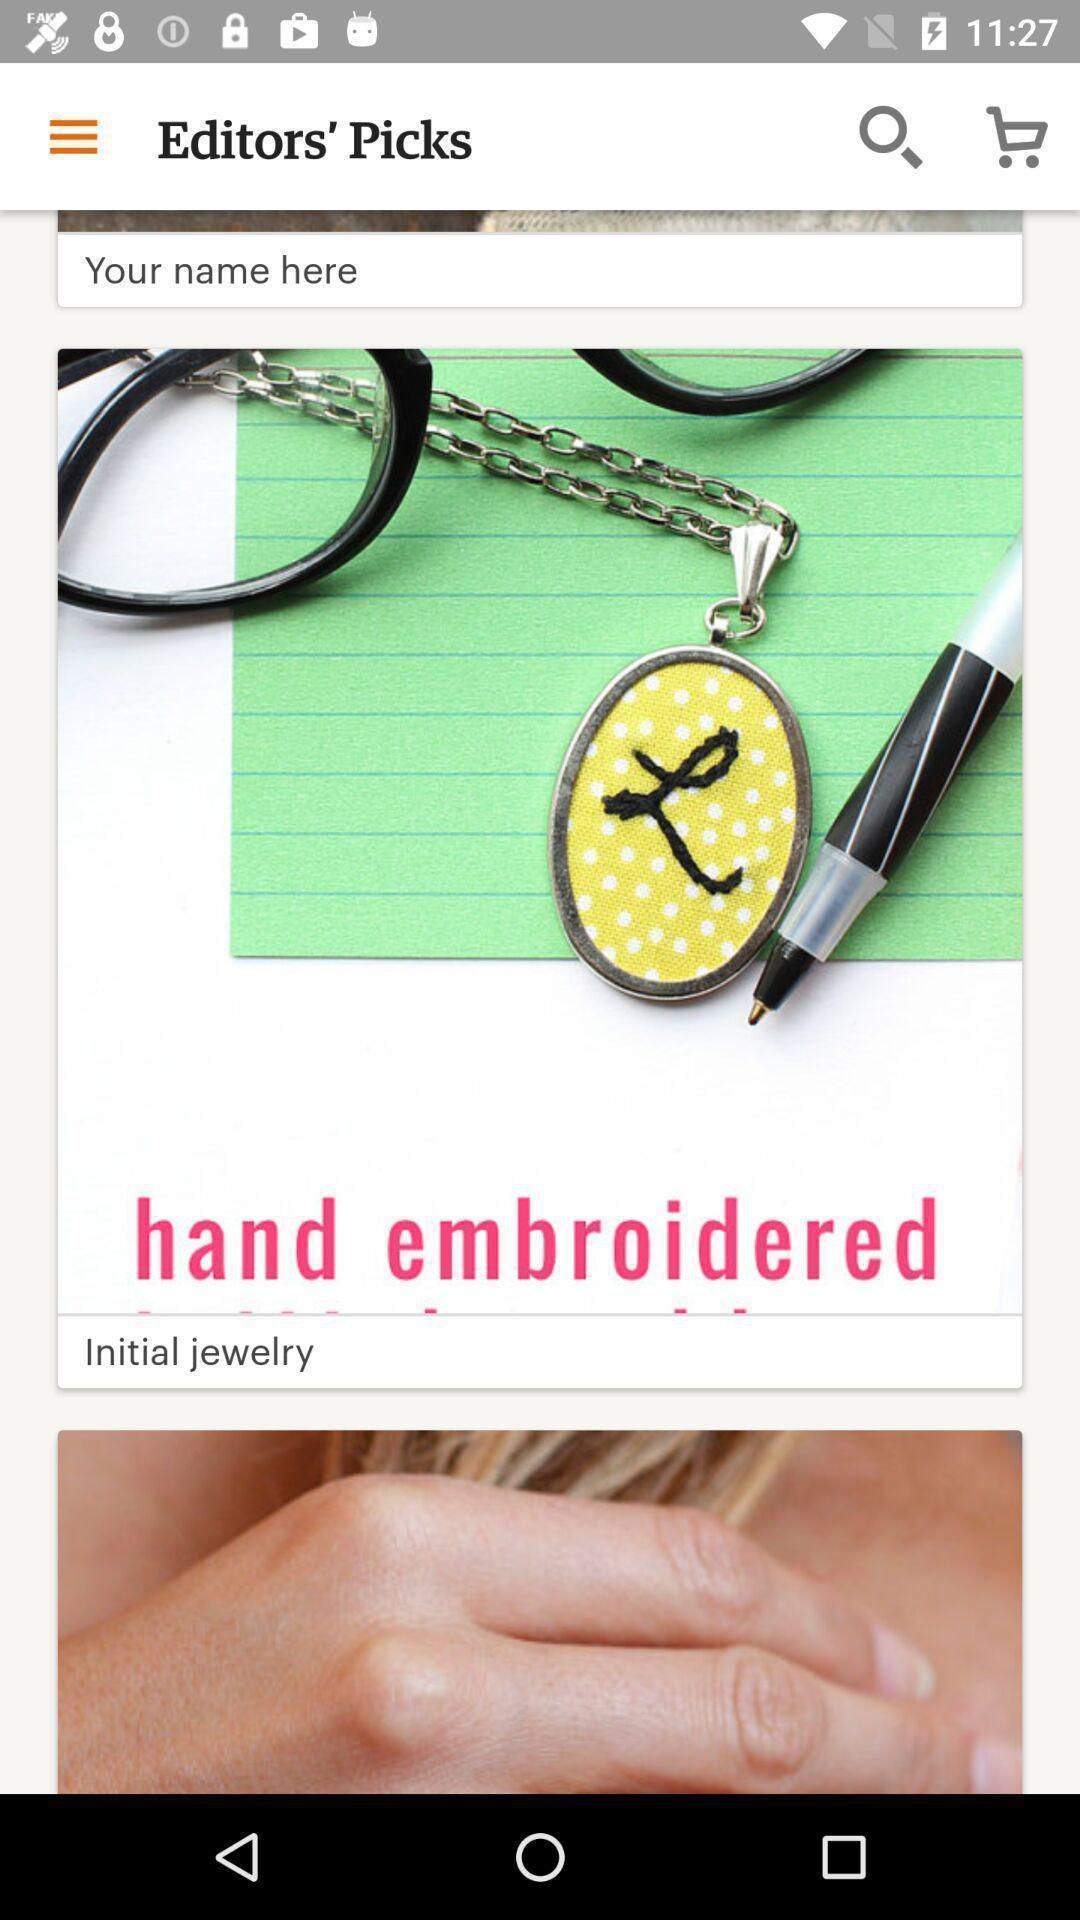Give me a summary of this screen capture. Page showing listings in a shopping related app. 